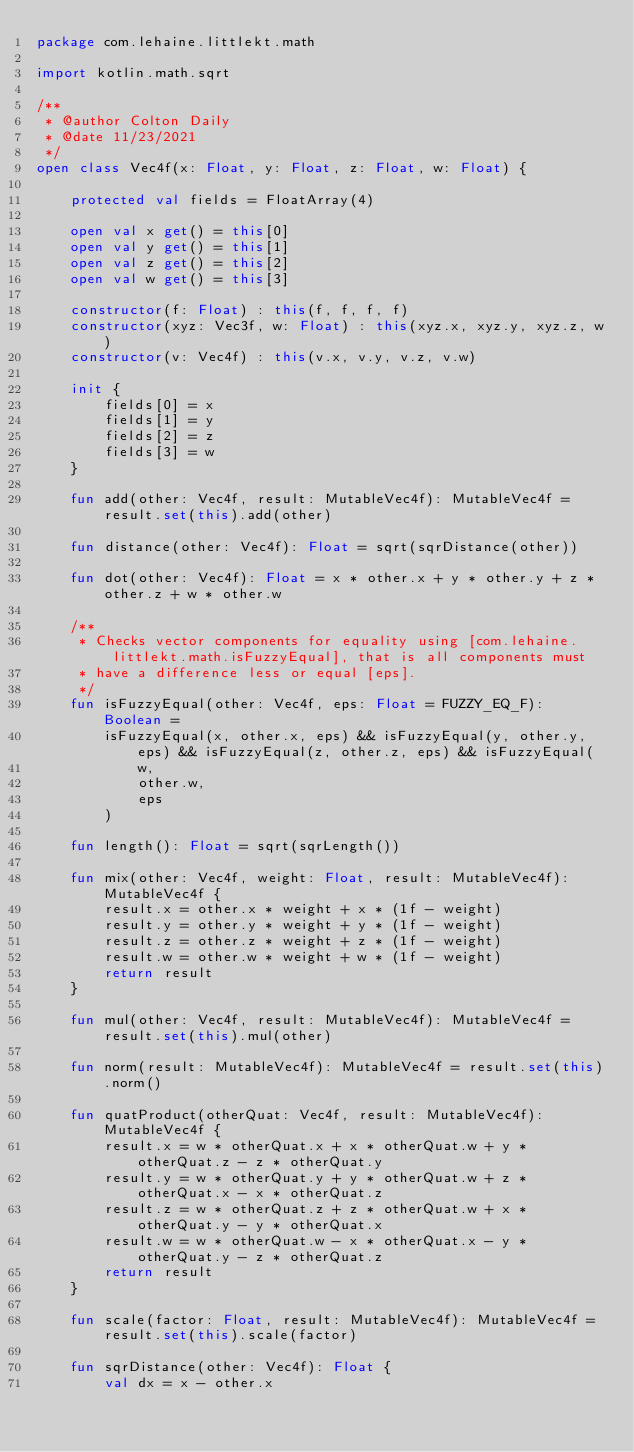Convert code to text. <code><loc_0><loc_0><loc_500><loc_500><_Kotlin_>package com.lehaine.littlekt.math

import kotlin.math.sqrt

/**
 * @author Colton Daily
 * @date 11/23/2021
 */
open class Vec4f(x: Float, y: Float, z: Float, w: Float) {

    protected val fields = FloatArray(4)

    open val x get() = this[0]
    open val y get() = this[1]
    open val z get() = this[2]
    open val w get() = this[3]

    constructor(f: Float) : this(f, f, f, f)
    constructor(xyz: Vec3f, w: Float) : this(xyz.x, xyz.y, xyz.z, w)
    constructor(v: Vec4f) : this(v.x, v.y, v.z, v.w)

    init {
        fields[0] = x
        fields[1] = y
        fields[2] = z
        fields[3] = w
    }

    fun add(other: Vec4f, result: MutableVec4f): MutableVec4f = result.set(this).add(other)

    fun distance(other: Vec4f): Float = sqrt(sqrDistance(other))

    fun dot(other: Vec4f): Float = x * other.x + y * other.y + z * other.z + w * other.w

    /**
     * Checks vector components for equality using [com.lehaine.littlekt.math.isFuzzyEqual], that is all components must
     * have a difference less or equal [eps].
     */
    fun isFuzzyEqual(other: Vec4f, eps: Float = FUZZY_EQ_F): Boolean =
        isFuzzyEqual(x, other.x, eps) && isFuzzyEqual(y, other.y, eps) && isFuzzyEqual(z, other.z, eps) && isFuzzyEqual(
            w,
            other.w,
            eps
        )

    fun length(): Float = sqrt(sqrLength())

    fun mix(other: Vec4f, weight: Float, result: MutableVec4f): MutableVec4f {
        result.x = other.x * weight + x * (1f - weight)
        result.y = other.y * weight + y * (1f - weight)
        result.z = other.z * weight + z * (1f - weight)
        result.w = other.w * weight + w * (1f - weight)
        return result
    }

    fun mul(other: Vec4f, result: MutableVec4f): MutableVec4f = result.set(this).mul(other)

    fun norm(result: MutableVec4f): MutableVec4f = result.set(this).norm()

    fun quatProduct(otherQuat: Vec4f, result: MutableVec4f): MutableVec4f {
        result.x = w * otherQuat.x + x * otherQuat.w + y * otherQuat.z - z * otherQuat.y
        result.y = w * otherQuat.y + y * otherQuat.w + z * otherQuat.x - x * otherQuat.z
        result.z = w * otherQuat.z + z * otherQuat.w + x * otherQuat.y - y * otherQuat.x
        result.w = w * otherQuat.w - x * otherQuat.x - y * otherQuat.y - z * otherQuat.z
        return result
    }

    fun scale(factor: Float, result: MutableVec4f): MutableVec4f = result.set(this).scale(factor)

    fun sqrDistance(other: Vec4f): Float {
        val dx = x - other.x</code> 